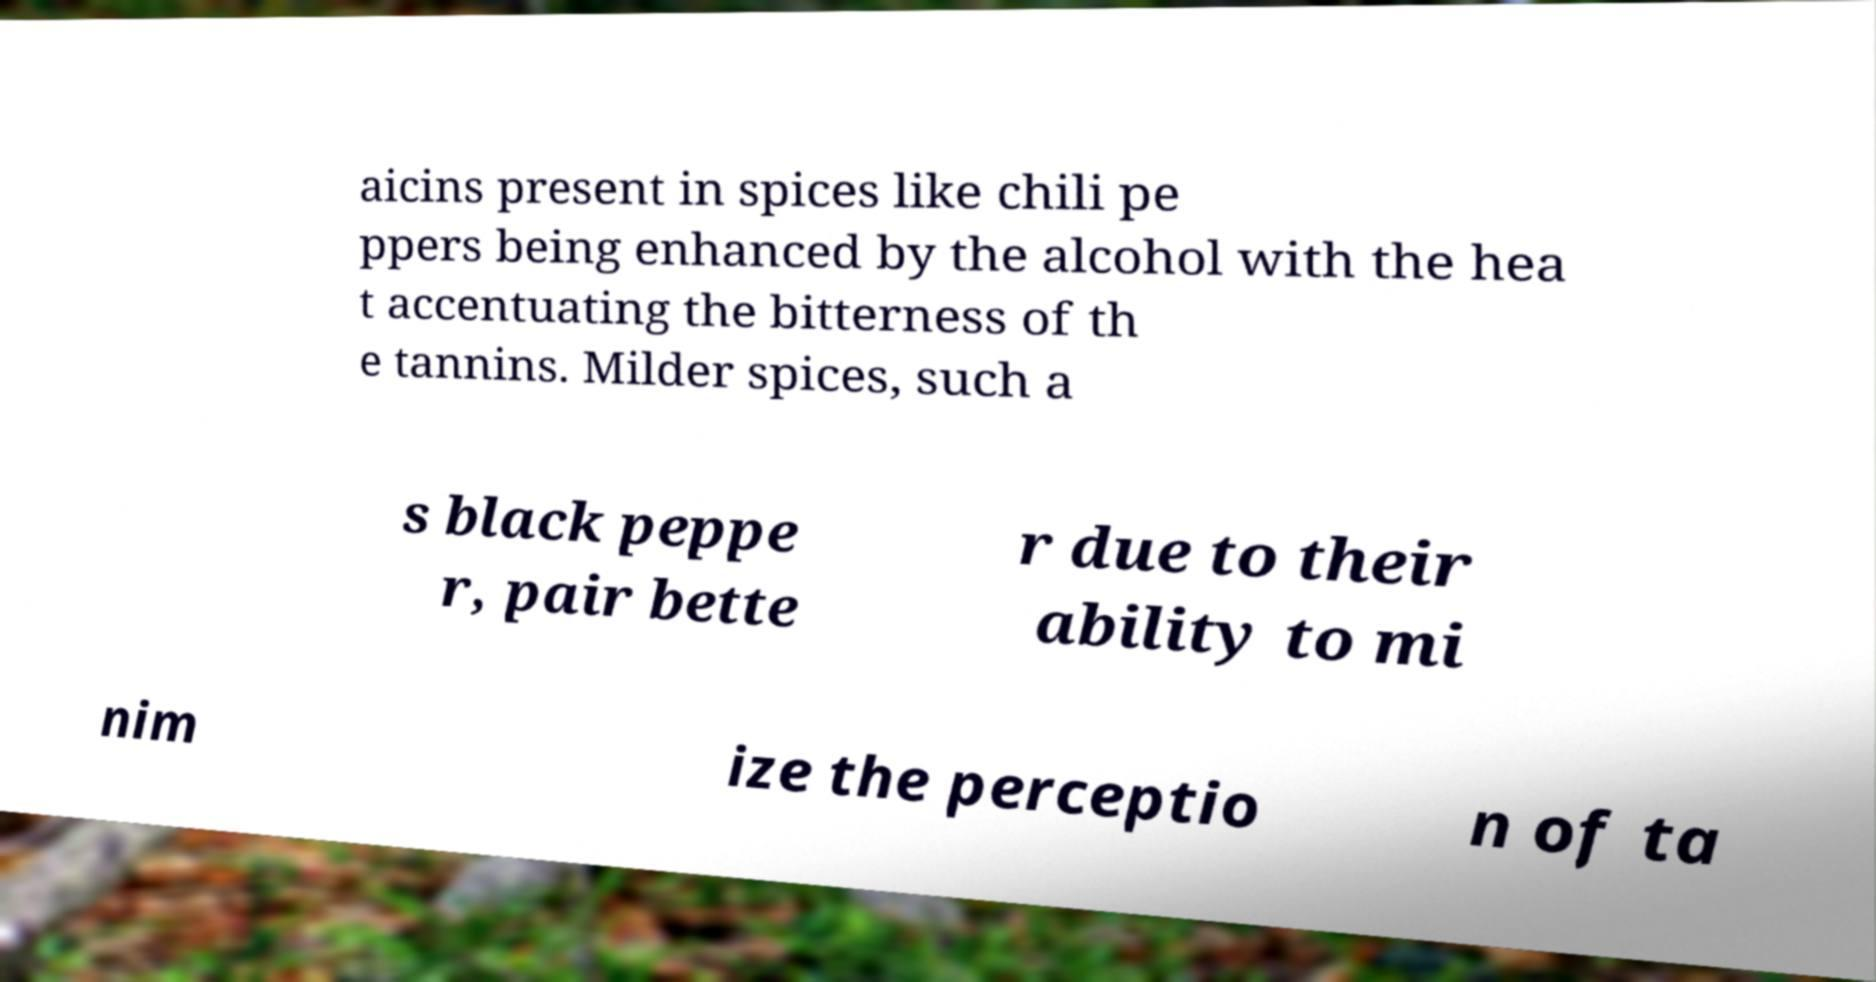Can you read and provide the text displayed in the image?This photo seems to have some interesting text. Can you extract and type it out for me? aicins present in spices like chili pe ppers being enhanced by the alcohol with the hea t accentuating the bitterness of th e tannins. Milder spices, such a s black peppe r, pair bette r due to their ability to mi nim ize the perceptio n of ta 